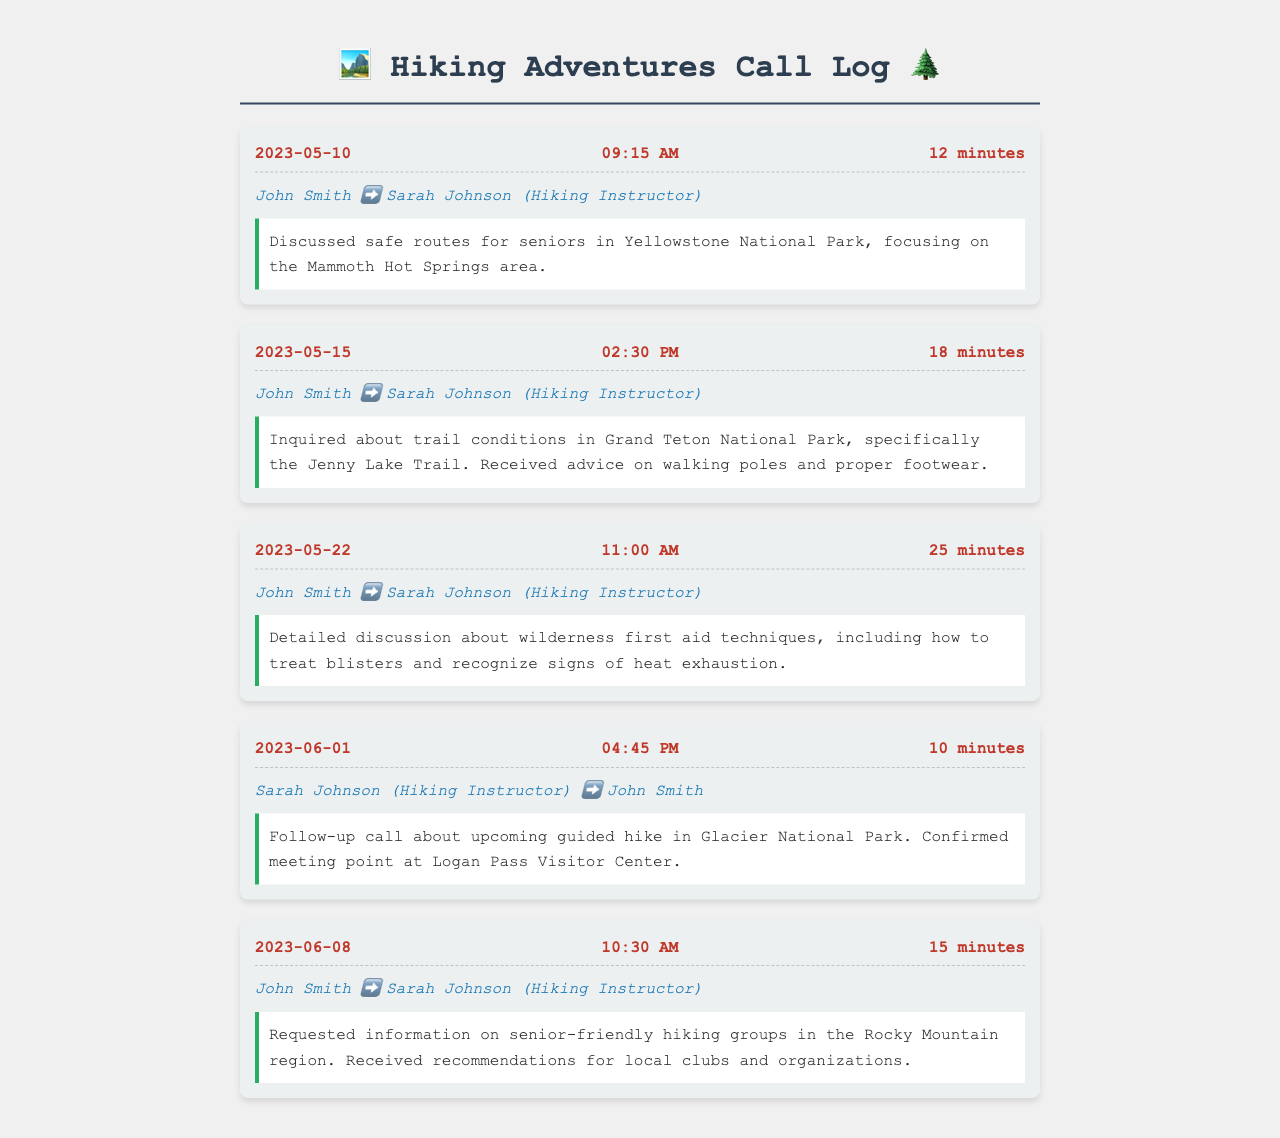What is the date of the first call? The first call date is the earliest recorded date in the log, which is May 10, 2023.
Answer: May 10, 2023 How long was the call on May 15? The duration of the second call on May 15 is listed as 18 minutes.
Answer: 18 minutes Who was on the call on June 1? The participants for the June 1 call include Sarah Johnson and John Smith, with Sarah being the instructor.
Answer: Sarah Johnson, John Smith What specific trail was discussed in the call on May 15? The call on May 15 specified discussion about the Jenny Lake Trail in Grand Teton National Park.
Answer: Jenny Lake Trail What topic was covered in the call on May 22? The main topic of the May 22 call was wilderness first aid techniques.
Answer: Wilderness first aid techniques How many calls are listed in the document? The total number of call logs present is 5, indicated by the entries under the call log section.
Answer: 5 What was confirmed during the June 1 call? The specific confirmation made during the June 1 call was regarding the meeting point at Logan Pass Visitor Center.
Answer: Meeting point at Logan Pass Visitor Center What is the focus of the first call regarding hiking routes? The first call focused on safe routes for seniors in the Mammoth Hot Springs area of Yellowstone National Park.
Answer: Safe routes for seniors in Mammoth Hot Springs What did John Smith request information on during the call on June 8? The request made by John Smith during the June 8 call was about senior-friendly hiking groups in the Rocky Mountain region.
Answer: Senior-friendly hiking groups 